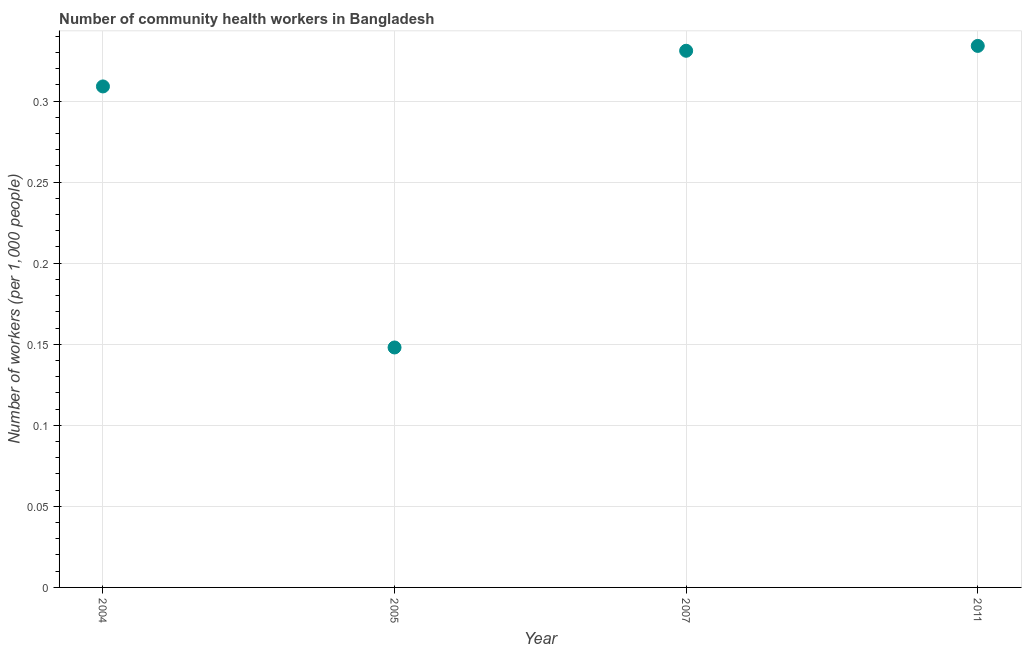What is the number of community health workers in 2005?
Ensure brevity in your answer.  0.15. Across all years, what is the maximum number of community health workers?
Provide a succinct answer. 0.33. Across all years, what is the minimum number of community health workers?
Offer a terse response. 0.15. In which year was the number of community health workers minimum?
Give a very brief answer. 2005. What is the sum of the number of community health workers?
Give a very brief answer. 1.12. What is the difference between the number of community health workers in 2005 and 2011?
Give a very brief answer. -0.19. What is the average number of community health workers per year?
Give a very brief answer. 0.28. What is the median number of community health workers?
Your answer should be very brief. 0.32. In how many years, is the number of community health workers greater than 0.27 ?
Ensure brevity in your answer.  3. Do a majority of the years between 2004 and 2007 (inclusive) have number of community health workers greater than 0.1 ?
Ensure brevity in your answer.  Yes. What is the ratio of the number of community health workers in 2005 to that in 2011?
Offer a very short reply. 0.44. Is the number of community health workers in 2005 less than that in 2007?
Provide a short and direct response. Yes. Is the difference between the number of community health workers in 2005 and 2011 greater than the difference between any two years?
Your response must be concise. Yes. What is the difference between the highest and the second highest number of community health workers?
Your answer should be very brief. 0. Is the sum of the number of community health workers in 2004 and 2011 greater than the maximum number of community health workers across all years?
Your response must be concise. Yes. What is the difference between the highest and the lowest number of community health workers?
Your response must be concise. 0.19. How many dotlines are there?
Provide a short and direct response. 1. How many years are there in the graph?
Ensure brevity in your answer.  4. What is the difference between two consecutive major ticks on the Y-axis?
Keep it short and to the point. 0.05. Are the values on the major ticks of Y-axis written in scientific E-notation?
Provide a succinct answer. No. Does the graph contain any zero values?
Your answer should be compact. No. Does the graph contain grids?
Your response must be concise. Yes. What is the title of the graph?
Offer a terse response. Number of community health workers in Bangladesh. What is the label or title of the Y-axis?
Give a very brief answer. Number of workers (per 1,0 people). What is the Number of workers (per 1,000 people) in 2004?
Make the answer very short. 0.31. What is the Number of workers (per 1,000 people) in 2005?
Make the answer very short. 0.15. What is the Number of workers (per 1,000 people) in 2007?
Your answer should be compact. 0.33. What is the Number of workers (per 1,000 people) in 2011?
Make the answer very short. 0.33. What is the difference between the Number of workers (per 1,000 people) in 2004 and 2005?
Provide a short and direct response. 0.16. What is the difference between the Number of workers (per 1,000 people) in 2004 and 2007?
Offer a very short reply. -0.02. What is the difference between the Number of workers (per 1,000 people) in 2004 and 2011?
Provide a succinct answer. -0.03. What is the difference between the Number of workers (per 1,000 people) in 2005 and 2007?
Your answer should be compact. -0.18. What is the difference between the Number of workers (per 1,000 people) in 2005 and 2011?
Your answer should be very brief. -0.19. What is the difference between the Number of workers (per 1,000 people) in 2007 and 2011?
Keep it short and to the point. -0. What is the ratio of the Number of workers (per 1,000 people) in 2004 to that in 2005?
Make the answer very short. 2.09. What is the ratio of the Number of workers (per 1,000 people) in 2004 to that in 2007?
Ensure brevity in your answer.  0.93. What is the ratio of the Number of workers (per 1,000 people) in 2004 to that in 2011?
Offer a very short reply. 0.93. What is the ratio of the Number of workers (per 1,000 people) in 2005 to that in 2007?
Give a very brief answer. 0.45. What is the ratio of the Number of workers (per 1,000 people) in 2005 to that in 2011?
Keep it short and to the point. 0.44. 